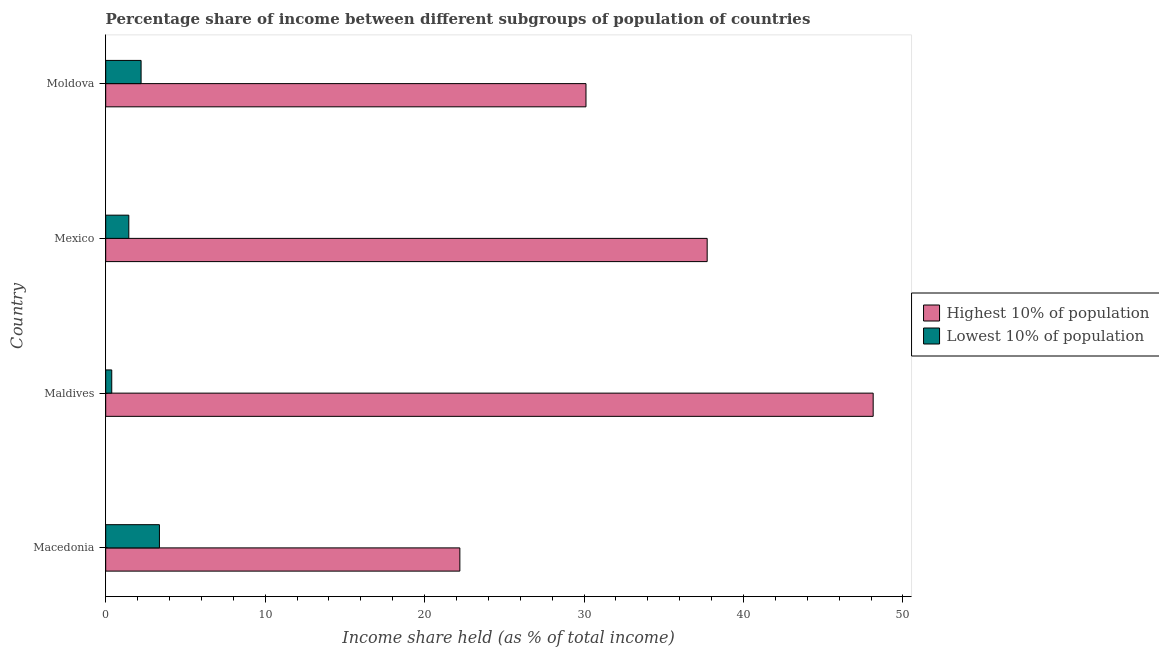How many different coloured bars are there?
Provide a short and direct response. 2. Are the number of bars per tick equal to the number of legend labels?
Your answer should be very brief. Yes. How many bars are there on the 4th tick from the top?
Keep it short and to the point. 2. What is the label of the 1st group of bars from the top?
Offer a terse response. Moldova. What is the income share held by lowest 10% of the population in Moldova?
Your response must be concise. 2.22. Across all countries, what is the maximum income share held by lowest 10% of the population?
Provide a short and direct response. 3.37. Across all countries, what is the minimum income share held by highest 10% of the population?
Provide a succinct answer. 22.21. In which country was the income share held by highest 10% of the population maximum?
Offer a very short reply. Maldives. In which country was the income share held by highest 10% of the population minimum?
Make the answer very short. Macedonia. What is the total income share held by lowest 10% of the population in the graph?
Ensure brevity in your answer.  7.42. What is the difference between the income share held by lowest 10% of the population in Mexico and that in Moldova?
Offer a terse response. -0.77. What is the difference between the income share held by lowest 10% of the population in Moldova and the income share held by highest 10% of the population in Maldives?
Your answer should be compact. -45.91. What is the average income share held by lowest 10% of the population per country?
Make the answer very short. 1.85. What is the difference between the income share held by highest 10% of the population and income share held by lowest 10% of the population in Mexico?
Provide a short and direct response. 36.27. What is the ratio of the income share held by lowest 10% of the population in Mexico to that in Moldova?
Offer a very short reply. 0.65. Is the income share held by highest 10% of the population in Maldives less than that in Moldova?
Give a very brief answer. No. What is the difference between the highest and the second highest income share held by highest 10% of the population?
Your answer should be compact. 10.41. What is the difference between the highest and the lowest income share held by lowest 10% of the population?
Your answer should be compact. 2.99. In how many countries, is the income share held by highest 10% of the population greater than the average income share held by highest 10% of the population taken over all countries?
Provide a short and direct response. 2. What does the 2nd bar from the top in Maldives represents?
Your response must be concise. Highest 10% of population. What does the 1st bar from the bottom in Macedonia represents?
Your answer should be very brief. Highest 10% of population. Are all the bars in the graph horizontal?
Give a very brief answer. Yes. How many countries are there in the graph?
Keep it short and to the point. 4. What is the difference between two consecutive major ticks on the X-axis?
Offer a very short reply. 10. Are the values on the major ticks of X-axis written in scientific E-notation?
Your response must be concise. No. Does the graph contain grids?
Make the answer very short. No. How are the legend labels stacked?
Your answer should be very brief. Vertical. What is the title of the graph?
Give a very brief answer. Percentage share of income between different subgroups of population of countries. Does "Working only" appear as one of the legend labels in the graph?
Ensure brevity in your answer.  No. What is the label or title of the X-axis?
Make the answer very short. Income share held (as % of total income). What is the label or title of the Y-axis?
Make the answer very short. Country. What is the Income share held (as % of total income) in Highest 10% of population in Macedonia?
Provide a short and direct response. 22.21. What is the Income share held (as % of total income) in Lowest 10% of population in Macedonia?
Your answer should be very brief. 3.37. What is the Income share held (as % of total income) of Highest 10% of population in Maldives?
Provide a short and direct response. 48.13. What is the Income share held (as % of total income) in Lowest 10% of population in Maldives?
Provide a succinct answer. 0.38. What is the Income share held (as % of total income) in Highest 10% of population in Mexico?
Offer a very short reply. 37.72. What is the Income share held (as % of total income) in Lowest 10% of population in Mexico?
Make the answer very short. 1.45. What is the Income share held (as % of total income) in Highest 10% of population in Moldova?
Offer a terse response. 30.12. What is the Income share held (as % of total income) in Lowest 10% of population in Moldova?
Your answer should be compact. 2.22. Across all countries, what is the maximum Income share held (as % of total income) in Highest 10% of population?
Provide a short and direct response. 48.13. Across all countries, what is the maximum Income share held (as % of total income) of Lowest 10% of population?
Keep it short and to the point. 3.37. Across all countries, what is the minimum Income share held (as % of total income) of Highest 10% of population?
Your answer should be very brief. 22.21. Across all countries, what is the minimum Income share held (as % of total income) of Lowest 10% of population?
Keep it short and to the point. 0.38. What is the total Income share held (as % of total income) in Highest 10% of population in the graph?
Your answer should be very brief. 138.18. What is the total Income share held (as % of total income) of Lowest 10% of population in the graph?
Keep it short and to the point. 7.42. What is the difference between the Income share held (as % of total income) in Highest 10% of population in Macedonia and that in Maldives?
Give a very brief answer. -25.92. What is the difference between the Income share held (as % of total income) in Lowest 10% of population in Macedonia and that in Maldives?
Offer a terse response. 2.99. What is the difference between the Income share held (as % of total income) in Highest 10% of population in Macedonia and that in Mexico?
Give a very brief answer. -15.51. What is the difference between the Income share held (as % of total income) of Lowest 10% of population in Macedonia and that in Mexico?
Your answer should be very brief. 1.92. What is the difference between the Income share held (as % of total income) in Highest 10% of population in Macedonia and that in Moldova?
Provide a short and direct response. -7.91. What is the difference between the Income share held (as % of total income) in Lowest 10% of population in Macedonia and that in Moldova?
Provide a succinct answer. 1.15. What is the difference between the Income share held (as % of total income) in Highest 10% of population in Maldives and that in Mexico?
Make the answer very short. 10.41. What is the difference between the Income share held (as % of total income) of Lowest 10% of population in Maldives and that in Mexico?
Your response must be concise. -1.07. What is the difference between the Income share held (as % of total income) of Highest 10% of population in Maldives and that in Moldova?
Your answer should be very brief. 18.01. What is the difference between the Income share held (as % of total income) of Lowest 10% of population in Maldives and that in Moldova?
Offer a terse response. -1.84. What is the difference between the Income share held (as % of total income) of Highest 10% of population in Mexico and that in Moldova?
Keep it short and to the point. 7.6. What is the difference between the Income share held (as % of total income) of Lowest 10% of population in Mexico and that in Moldova?
Keep it short and to the point. -0.77. What is the difference between the Income share held (as % of total income) of Highest 10% of population in Macedonia and the Income share held (as % of total income) of Lowest 10% of population in Maldives?
Give a very brief answer. 21.83. What is the difference between the Income share held (as % of total income) in Highest 10% of population in Macedonia and the Income share held (as % of total income) in Lowest 10% of population in Mexico?
Ensure brevity in your answer.  20.76. What is the difference between the Income share held (as % of total income) of Highest 10% of population in Macedonia and the Income share held (as % of total income) of Lowest 10% of population in Moldova?
Keep it short and to the point. 19.99. What is the difference between the Income share held (as % of total income) of Highest 10% of population in Maldives and the Income share held (as % of total income) of Lowest 10% of population in Mexico?
Keep it short and to the point. 46.68. What is the difference between the Income share held (as % of total income) in Highest 10% of population in Maldives and the Income share held (as % of total income) in Lowest 10% of population in Moldova?
Keep it short and to the point. 45.91. What is the difference between the Income share held (as % of total income) of Highest 10% of population in Mexico and the Income share held (as % of total income) of Lowest 10% of population in Moldova?
Give a very brief answer. 35.5. What is the average Income share held (as % of total income) in Highest 10% of population per country?
Your answer should be compact. 34.55. What is the average Income share held (as % of total income) of Lowest 10% of population per country?
Your answer should be very brief. 1.85. What is the difference between the Income share held (as % of total income) in Highest 10% of population and Income share held (as % of total income) in Lowest 10% of population in Macedonia?
Your answer should be very brief. 18.84. What is the difference between the Income share held (as % of total income) in Highest 10% of population and Income share held (as % of total income) in Lowest 10% of population in Maldives?
Offer a very short reply. 47.75. What is the difference between the Income share held (as % of total income) of Highest 10% of population and Income share held (as % of total income) of Lowest 10% of population in Mexico?
Give a very brief answer. 36.27. What is the difference between the Income share held (as % of total income) in Highest 10% of population and Income share held (as % of total income) in Lowest 10% of population in Moldova?
Your answer should be compact. 27.9. What is the ratio of the Income share held (as % of total income) in Highest 10% of population in Macedonia to that in Maldives?
Your answer should be compact. 0.46. What is the ratio of the Income share held (as % of total income) of Lowest 10% of population in Macedonia to that in Maldives?
Your response must be concise. 8.87. What is the ratio of the Income share held (as % of total income) in Highest 10% of population in Macedonia to that in Mexico?
Keep it short and to the point. 0.59. What is the ratio of the Income share held (as % of total income) in Lowest 10% of population in Macedonia to that in Mexico?
Offer a terse response. 2.32. What is the ratio of the Income share held (as % of total income) in Highest 10% of population in Macedonia to that in Moldova?
Provide a succinct answer. 0.74. What is the ratio of the Income share held (as % of total income) in Lowest 10% of population in Macedonia to that in Moldova?
Offer a very short reply. 1.52. What is the ratio of the Income share held (as % of total income) in Highest 10% of population in Maldives to that in Mexico?
Provide a succinct answer. 1.28. What is the ratio of the Income share held (as % of total income) in Lowest 10% of population in Maldives to that in Mexico?
Provide a short and direct response. 0.26. What is the ratio of the Income share held (as % of total income) in Highest 10% of population in Maldives to that in Moldova?
Your answer should be very brief. 1.6. What is the ratio of the Income share held (as % of total income) in Lowest 10% of population in Maldives to that in Moldova?
Ensure brevity in your answer.  0.17. What is the ratio of the Income share held (as % of total income) of Highest 10% of population in Mexico to that in Moldova?
Your response must be concise. 1.25. What is the ratio of the Income share held (as % of total income) of Lowest 10% of population in Mexico to that in Moldova?
Offer a very short reply. 0.65. What is the difference between the highest and the second highest Income share held (as % of total income) of Highest 10% of population?
Make the answer very short. 10.41. What is the difference between the highest and the second highest Income share held (as % of total income) in Lowest 10% of population?
Give a very brief answer. 1.15. What is the difference between the highest and the lowest Income share held (as % of total income) of Highest 10% of population?
Give a very brief answer. 25.92. What is the difference between the highest and the lowest Income share held (as % of total income) in Lowest 10% of population?
Give a very brief answer. 2.99. 